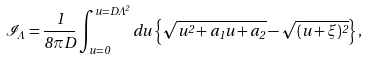Convert formula to latex. <formula><loc_0><loc_0><loc_500><loc_500>\mathcal { I } _ { \Lambda } = \frac { 1 } { 8 \pi D } \int _ { u = 0 } ^ { u = D \Lambda ^ { 2 } } d u \left \{ \sqrt { u ^ { 2 } + a _ { 1 } u + a _ { 2 } } - \sqrt { ( u + \xi ) ^ { 2 } } \right \} ,</formula> 